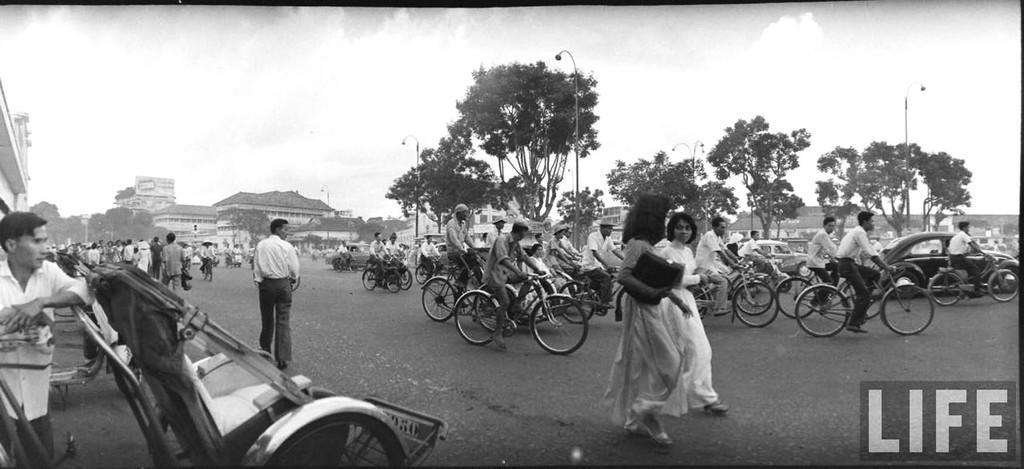How would you summarize this image in a sentence or two? It is a black and white picture it looks like an old picture,there are some people riding bicycles on the road and walking on the road,to the roadside there are some other vehicles many people are also walking,in the background there are some buildings trees and mountains. 